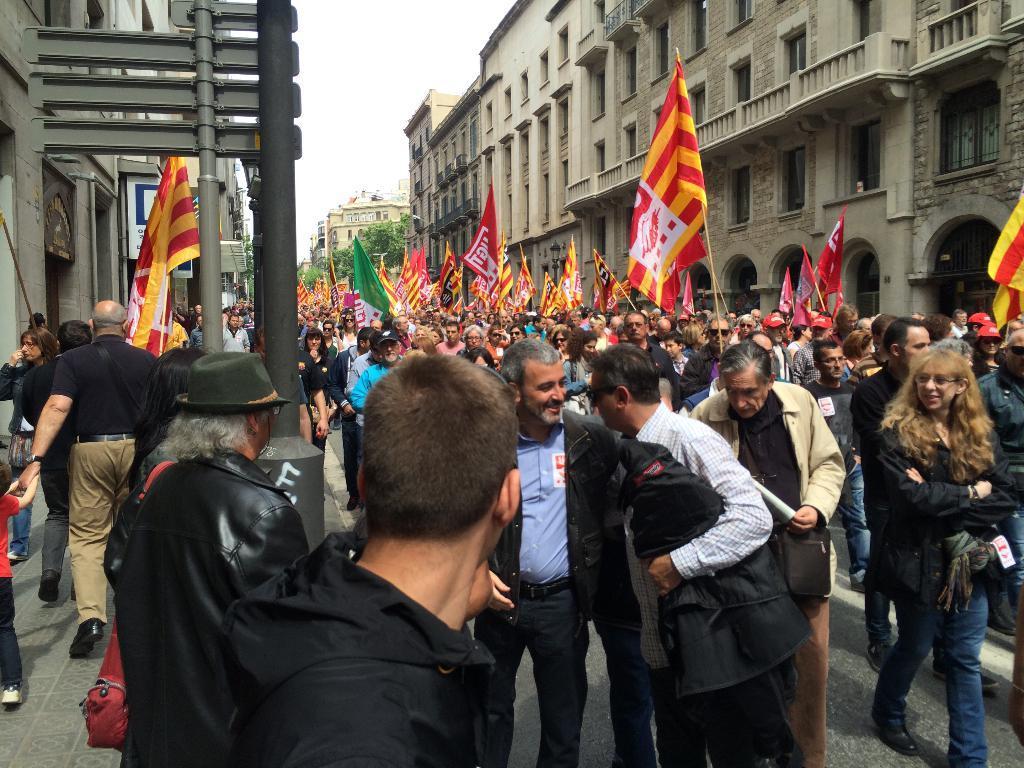Describe this image in one or two sentences. In this image, at the left side there is a path, there is a black color pole, at the right side there are some people walking and they are holding some flags, there are some buildings, at the top there is a sky. 